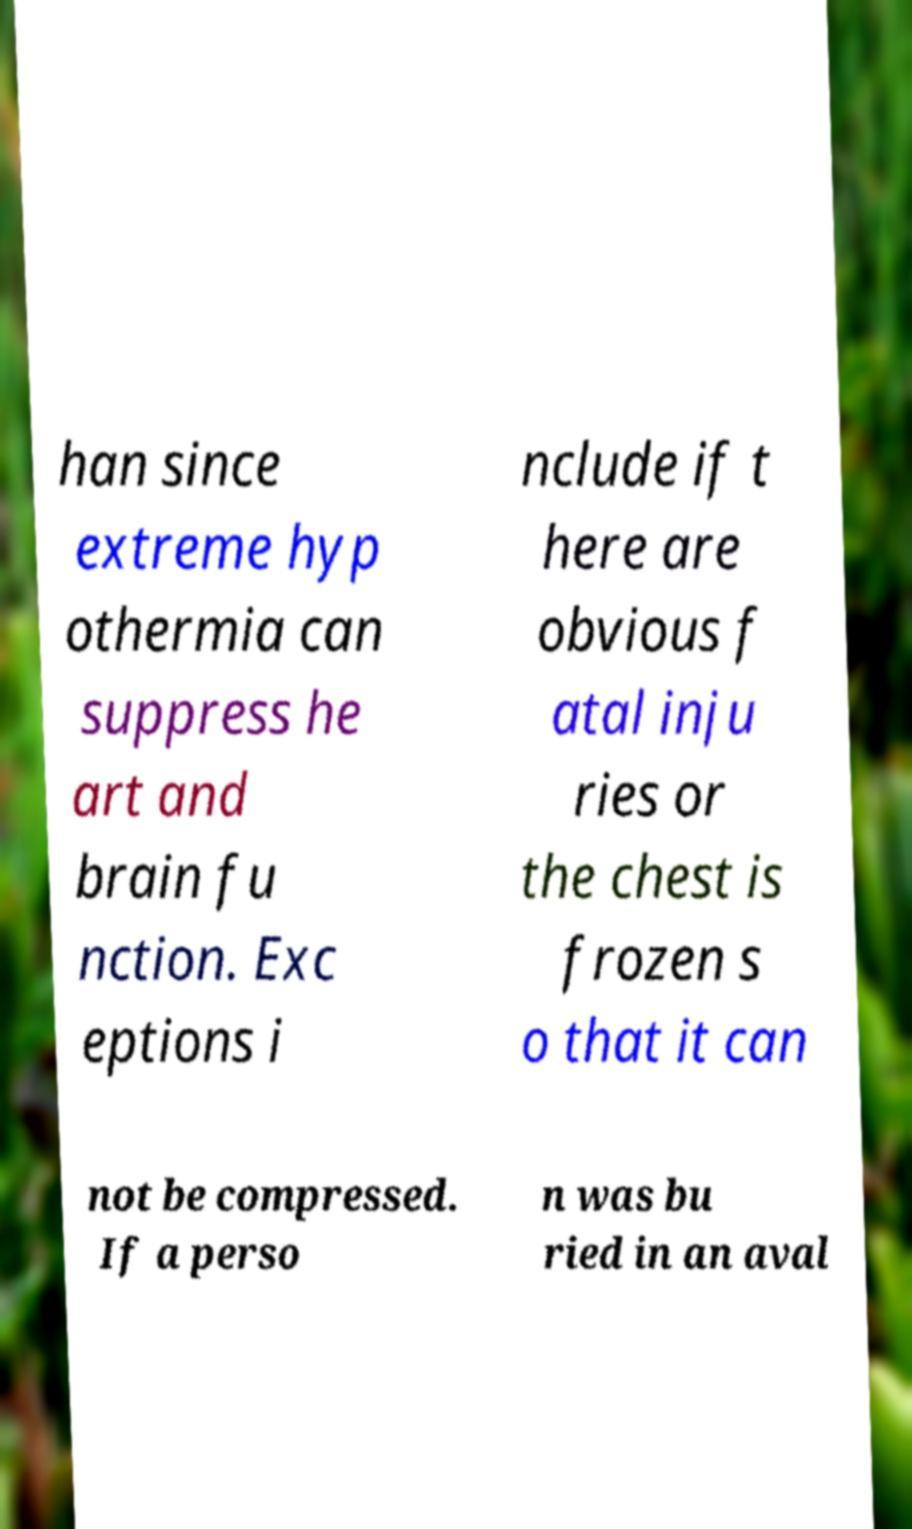Please identify and transcribe the text found in this image. han since extreme hyp othermia can suppress he art and brain fu nction. Exc eptions i nclude if t here are obvious f atal inju ries or the chest is frozen s o that it can not be compressed. If a perso n was bu ried in an aval 